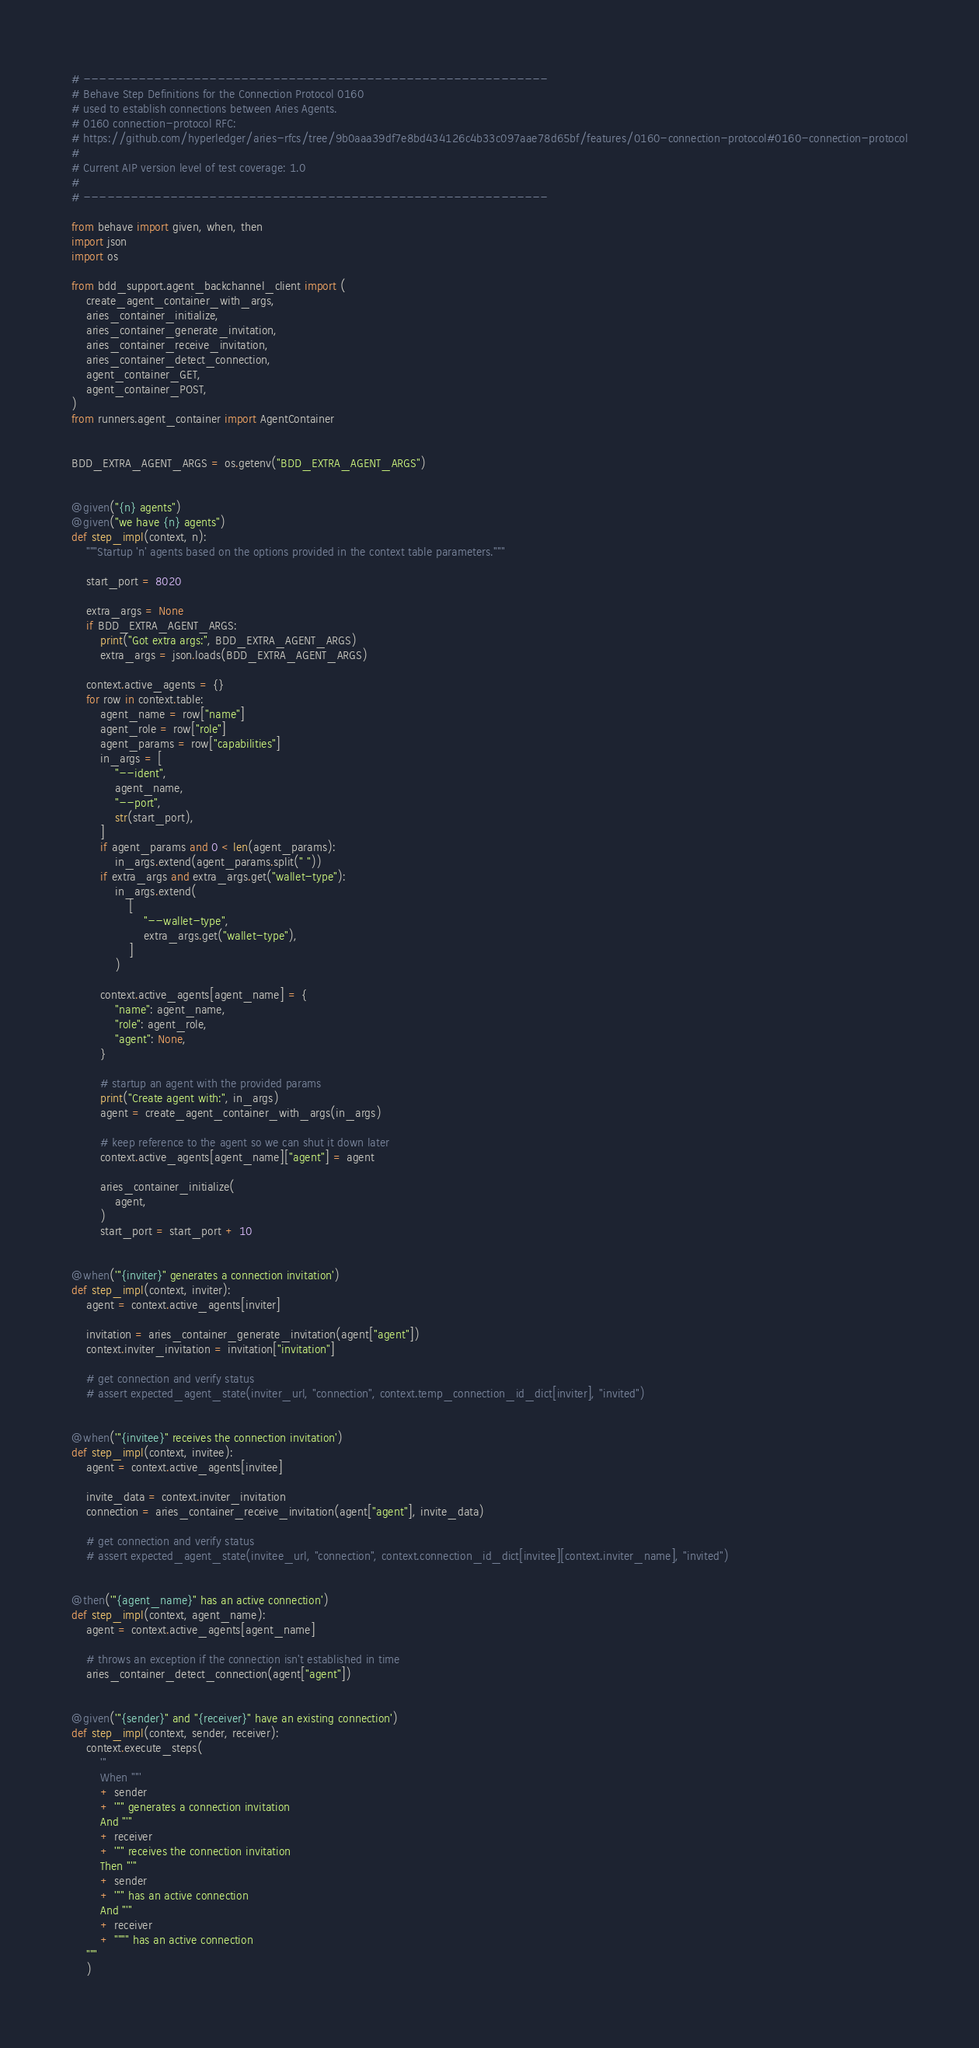Convert code to text. <code><loc_0><loc_0><loc_500><loc_500><_Python_># -----------------------------------------------------------
# Behave Step Definitions for the Connection Protocol 0160
# used to establish connections between Aries Agents.
# 0160 connection-protocol RFC:
# https://github.com/hyperledger/aries-rfcs/tree/9b0aaa39df7e8bd434126c4b33c097aae78d65bf/features/0160-connection-protocol#0160-connection-protocol
#
# Current AIP version level of test coverage: 1.0
#
# -----------------------------------------------------------

from behave import given, when, then
import json
import os

from bdd_support.agent_backchannel_client import (
    create_agent_container_with_args,
    aries_container_initialize,
    aries_container_generate_invitation,
    aries_container_receive_invitation,
    aries_container_detect_connection,
    agent_container_GET,
    agent_container_POST,
)
from runners.agent_container import AgentContainer


BDD_EXTRA_AGENT_ARGS = os.getenv("BDD_EXTRA_AGENT_ARGS")


@given("{n} agents")
@given("we have {n} agents")
def step_impl(context, n):
    """Startup 'n' agents based on the options provided in the context table parameters."""

    start_port = 8020

    extra_args = None
    if BDD_EXTRA_AGENT_ARGS:
        print("Got extra args:", BDD_EXTRA_AGENT_ARGS)
        extra_args = json.loads(BDD_EXTRA_AGENT_ARGS)

    context.active_agents = {}
    for row in context.table:
        agent_name = row["name"]
        agent_role = row["role"]
        agent_params = row["capabilities"]
        in_args = [
            "--ident",
            agent_name,
            "--port",
            str(start_port),
        ]
        if agent_params and 0 < len(agent_params):
            in_args.extend(agent_params.split(" "))
        if extra_args and extra_args.get("wallet-type"):
            in_args.extend(
                [
                    "--wallet-type",
                    extra_args.get("wallet-type"),
                ]
            )

        context.active_agents[agent_name] = {
            "name": agent_name,
            "role": agent_role,
            "agent": None,
        }

        # startup an agent with the provided params
        print("Create agent with:", in_args)
        agent = create_agent_container_with_args(in_args)

        # keep reference to the agent so we can shut it down later
        context.active_agents[agent_name]["agent"] = agent

        aries_container_initialize(
            agent,
        )
        start_port = start_port + 10


@when('"{inviter}" generates a connection invitation')
def step_impl(context, inviter):
    agent = context.active_agents[inviter]

    invitation = aries_container_generate_invitation(agent["agent"])
    context.inviter_invitation = invitation["invitation"]

    # get connection and verify status
    # assert expected_agent_state(inviter_url, "connection", context.temp_connection_id_dict[inviter], "invited")


@when('"{invitee}" receives the connection invitation')
def step_impl(context, invitee):
    agent = context.active_agents[invitee]

    invite_data = context.inviter_invitation
    connection = aries_container_receive_invitation(agent["agent"], invite_data)

    # get connection and verify status
    # assert expected_agent_state(invitee_url, "connection", context.connection_id_dict[invitee][context.inviter_name], "invited")


@then('"{agent_name}" has an active connection')
def step_impl(context, agent_name):
    agent = context.active_agents[agent_name]

    # throws an exception if the connection isn't established in time
    aries_container_detect_connection(agent["agent"])


@given('"{sender}" and "{receiver}" have an existing connection')
def step_impl(context, sender, receiver):
    context.execute_steps(
        '''
        When "'''
        + sender
        + '''" generates a connection invitation
        And "'''
        + receiver
        + '''" receives the connection invitation
        Then "'''
        + sender
        + '''" has an active connection
        And "'''
        + receiver
        + """" has an active connection
    """
    )
</code> 